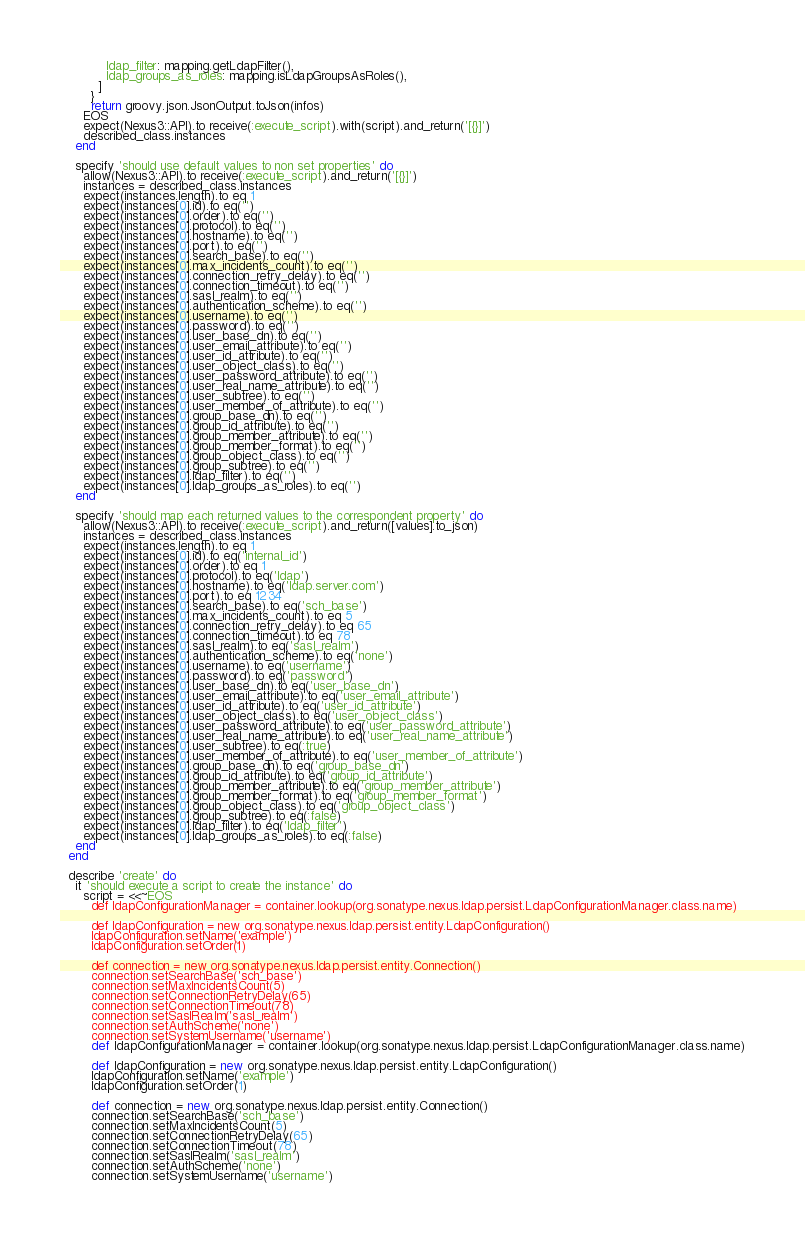<code> <loc_0><loc_0><loc_500><loc_500><_Ruby_>            ldap_filter: mapping.getLdapFilter(),
            ldap_groups_as_roles: mapping.isLdapGroupsAsRoles(),
          ]
        }
        return groovy.json.JsonOutput.toJson(infos)
      EOS
      expect(Nexus3::API).to receive(:execute_script).with(script).and_return('[{}]')
      described_class.instances
    end

    specify 'should use default values to non set properties' do
      allow(Nexus3::API).to receive(:execute_script).and_return('[{}]')
      instances = described_class.instances
      expect(instances.length).to eq 1
      expect(instances[0].id).to eq('')
      expect(instances[0].order).to eq('')
      expect(instances[0].protocol).to eq('')
      expect(instances[0].hostname).to eq('')
      expect(instances[0].port).to eq('')
      expect(instances[0].search_base).to eq('')
      expect(instances[0].max_incidents_count).to eq('')
      expect(instances[0].connection_retry_delay).to eq('')
      expect(instances[0].connection_timeout).to eq('')
      expect(instances[0].sasl_realm).to eq('')
      expect(instances[0].authentication_scheme).to eq('')
      expect(instances[0].username).to eq('')
      expect(instances[0].password).to eq('')
      expect(instances[0].user_base_dn).to eq('')
      expect(instances[0].user_email_attribute).to eq('')
      expect(instances[0].user_id_attribute).to eq('')
      expect(instances[0].user_object_class).to eq('')
      expect(instances[0].user_password_attribute).to eq('')
      expect(instances[0].user_real_name_attribute).to eq('')
      expect(instances[0].user_subtree).to eq('')
      expect(instances[0].user_member_of_attribute).to eq('')
      expect(instances[0].group_base_dn).to eq('')
      expect(instances[0].group_id_attribute).to eq('')
      expect(instances[0].group_member_attribute).to eq('')
      expect(instances[0].group_member_format).to eq('')
      expect(instances[0].group_object_class).to eq('')
      expect(instances[0].group_subtree).to eq('')
      expect(instances[0].ldap_filter).to eq('')
      expect(instances[0].ldap_groups_as_roles).to eq('')
    end

    specify 'should map each returned values to the correspondent property' do
      allow(Nexus3::API).to receive(:execute_script).and_return([values].to_json)
      instances = described_class.instances
      expect(instances.length).to eq 1
      expect(instances[0].id).to eq('internal_id')
      expect(instances[0].order).to eq 1
      expect(instances[0].protocol).to eq('ldap')
      expect(instances[0].hostname).to eq('ldap.server.com')
      expect(instances[0].port).to eq 1234
      expect(instances[0].search_base).to eq('sch_base')
      expect(instances[0].max_incidents_count).to eq 5
      expect(instances[0].connection_retry_delay).to eq 65
      expect(instances[0].connection_timeout).to eq 78
      expect(instances[0].sasl_realm).to eq('sasl_realm')
      expect(instances[0].authentication_scheme).to eq('none')
      expect(instances[0].username).to eq('username')
      expect(instances[0].password).to eq('password')
      expect(instances[0].user_base_dn).to eq('user_base_dn')
      expect(instances[0].user_email_attribute).to eq('user_email_attribute')
      expect(instances[0].user_id_attribute).to eq('user_id_attribute')
      expect(instances[0].user_object_class).to eq('user_object_class')
      expect(instances[0].user_password_attribute).to eq('user_password_attribute')
      expect(instances[0].user_real_name_attribute).to eq('user_real_name_attribute')
      expect(instances[0].user_subtree).to eq(:true)
      expect(instances[0].user_member_of_attribute).to eq('user_member_of_attribute')
      expect(instances[0].group_base_dn).to eq('group_base_dn')
      expect(instances[0].group_id_attribute).to eq('group_id_attribute')
      expect(instances[0].group_member_attribute).to eq('group_member_attribute')
      expect(instances[0].group_member_format).to eq('group_member_format')
      expect(instances[0].group_object_class).to eq('group_object_class')
      expect(instances[0].group_subtree).to eq(:false)
      expect(instances[0].ldap_filter).to eq('ldap_filter')
      expect(instances[0].ldap_groups_as_roles).to eq(:false)
    end
  end

  describe 'create' do
    it 'should execute a script to create the instance' do
      script = <<~EOS
        def ldapConfigurationManager = container.lookup(org.sonatype.nexus.ldap.persist.LdapConfigurationManager.class.name)

        def ldapConfiguration = new org.sonatype.nexus.ldap.persist.entity.LdapConfiguration()
        ldapConfiguration.setName('example')
        ldapConfiguration.setOrder(1)
        
        def connection = new org.sonatype.nexus.ldap.persist.entity.Connection()
        connection.setSearchBase('sch_base')
        connection.setMaxIncidentsCount(5)
        connection.setConnectionRetryDelay(65)
        connection.setConnectionTimeout(78)
        connection.setSaslRealm('sasl_realm')
        connection.setAuthScheme('none')
        connection.setSystemUsername('username')</code> 